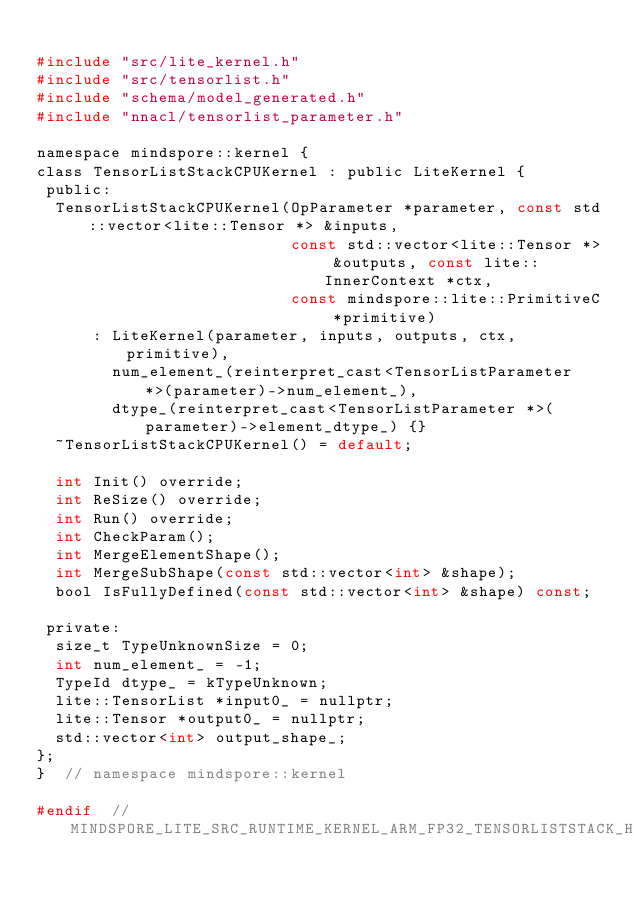<code> <loc_0><loc_0><loc_500><loc_500><_C_>
#include "src/lite_kernel.h"
#include "src/tensorlist.h"
#include "schema/model_generated.h"
#include "nnacl/tensorlist_parameter.h"

namespace mindspore::kernel {
class TensorListStackCPUKernel : public LiteKernel {
 public:
  TensorListStackCPUKernel(OpParameter *parameter, const std::vector<lite::Tensor *> &inputs,
                           const std::vector<lite::Tensor *> &outputs, const lite::InnerContext *ctx,
                           const mindspore::lite::PrimitiveC *primitive)
      : LiteKernel(parameter, inputs, outputs, ctx, primitive),
        num_element_(reinterpret_cast<TensorListParameter *>(parameter)->num_element_),
        dtype_(reinterpret_cast<TensorListParameter *>(parameter)->element_dtype_) {}
  ~TensorListStackCPUKernel() = default;

  int Init() override;
  int ReSize() override;
  int Run() override;
  int CheckParam();
  int MergeElementShape();
  int MergeSubShape(const std::vector<int> &shape);
  bool IsFullyDefined(const std::vector<int> &shape) const;

 private:
  size_t TypeUnknownSize = 0;
  int num_element_ = -1;
  TypeId dtype_ = kTypeUnknown;
  lite::TensorList *input0_ = nullptr;
  lite::Tensor *output0_ = nullptr;
  std::vector<int> output_shape_;
};
}  // namespace mindspore::kernel

#endif  // MINDSPORE_LITE_SRC_RUNTIME_KERNEL_ARM_FP32_TENSORLISTSTACK_H_
</code> 